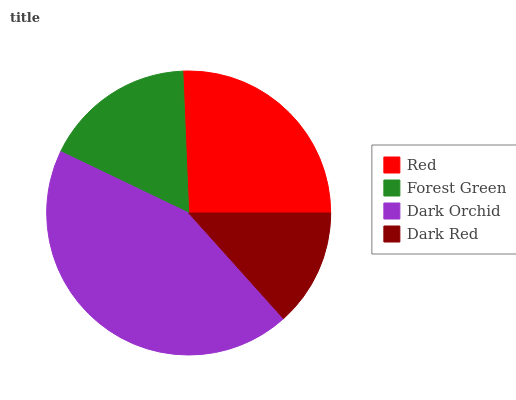Is Dark Red the minimum?
Answer yes or no. Yes. Is Dark Orchid the maximum?
Answer yes or no. Yes. Is Forest Green the minimum?
Answer yes or no. No. Is Forest Green the maximum?
Answer yes or no. No. Is Red greater than Forest Green?
Answer yes or no. Yes. Is Forest Green less than Red?
Answer yes or no. Yes. Is Forest Green greater than Red?
Answer yes or no. No. Is Red less than Forest Green?
Answer yes or no. No. Is Red the high median?
Answer yes or no. Yes. Is Forest Green the low median?
Answer yes or no. Yes. Is Dark Red the high median?
Answer yes or no. No. Is Dark Red the low median?
Answer yes or no. No. 